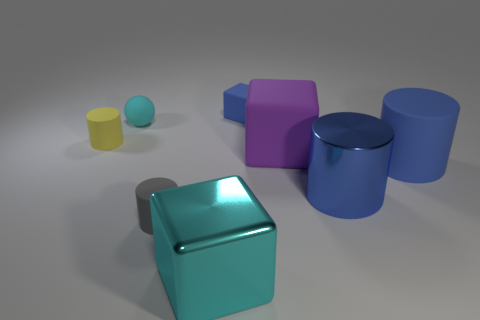Subtract 1 cylinders. How many cylinders are left? 3 Add 1 big blue rubber objects. How many objects exist? 9 Subtract all cubes. How many objects are left? 5 Subtract all cyan spheres. Subtract all small matte cubes. How many objects are left? 6 Add 4 purple rubber blocks. How many purple rubber blocks are left? 5 Add 4 matte cylinders. How many matte cylinders exist? 7 Subtract 0 yellow blocks. How many objects are left? 8 